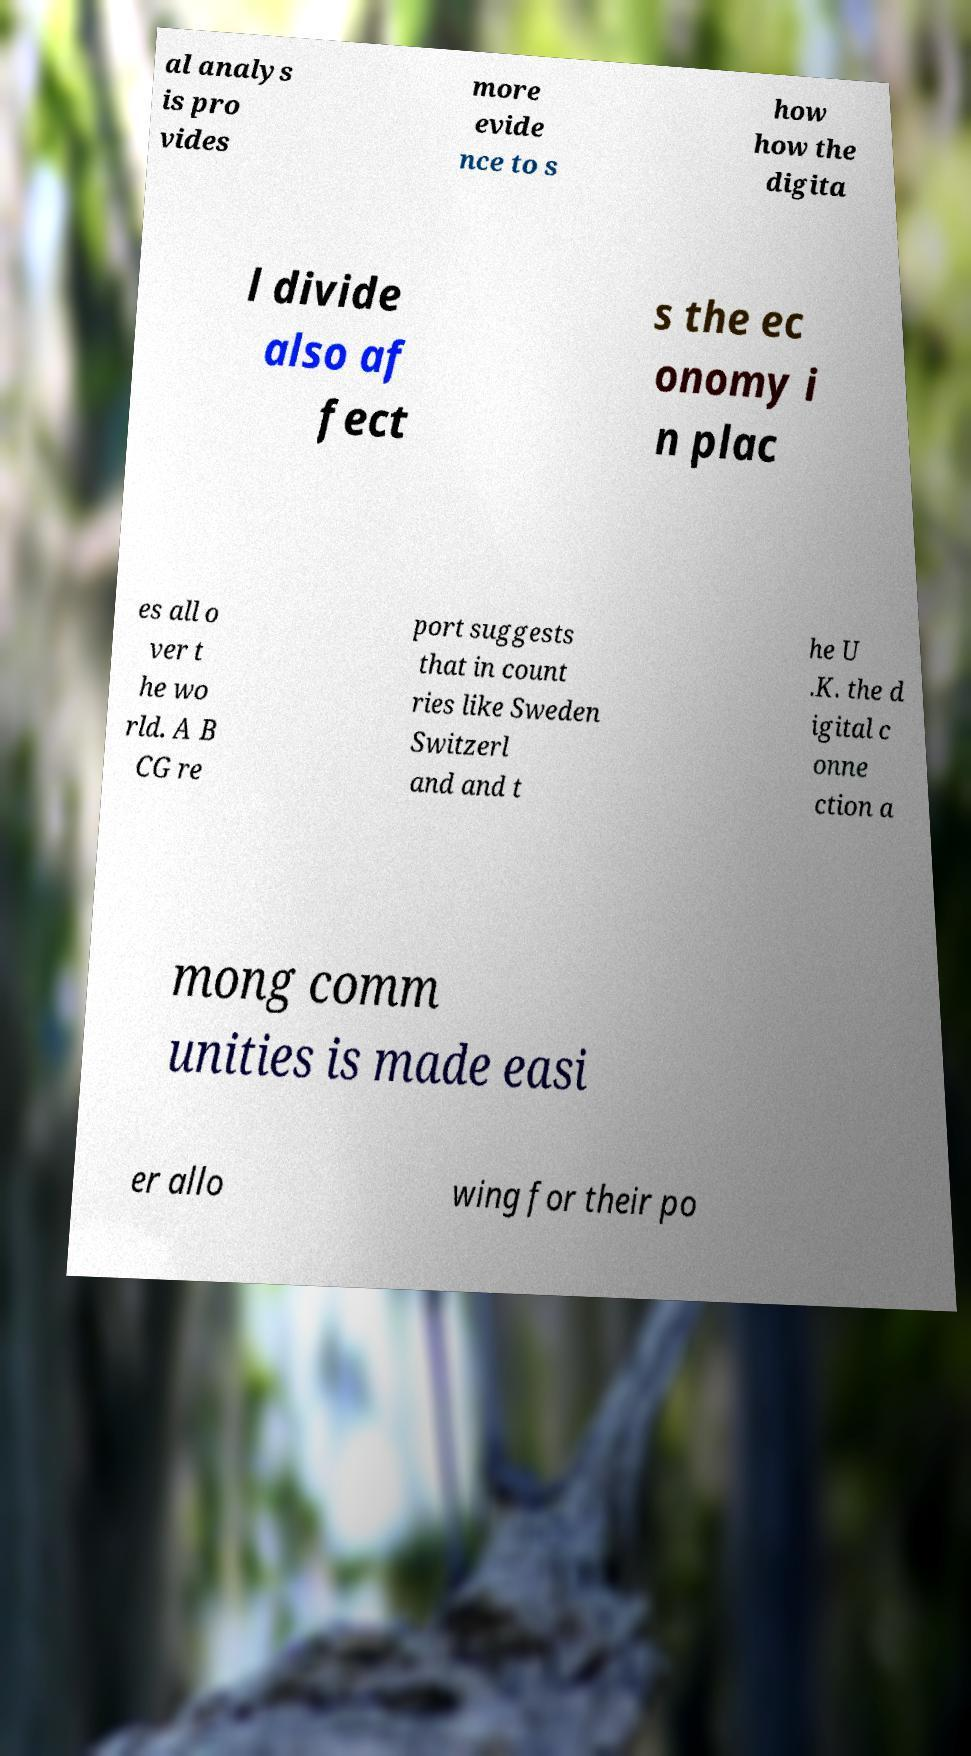I need the written content from this picture converted into text. Can you do that? al analys is pro vides more evide nce to s how how the digita l divide also af fect s the ec onomy i n plac es all o ver t he wo rld. A B CG re port suggests that in count ries like Sweden Switzerl and and t he U .K. the d igital c onne ction a mong comm unities is made easi er allo wing for their po 